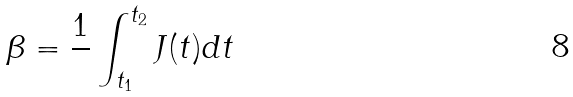Convert formula to latex. <formula><loc_0><loc_0><loc_500><loc_500>\beta = \frac { 1 } { } \int _ { t _ { 1 } } ^ { t _ { 2 } } J ( t ) d t</formula> 